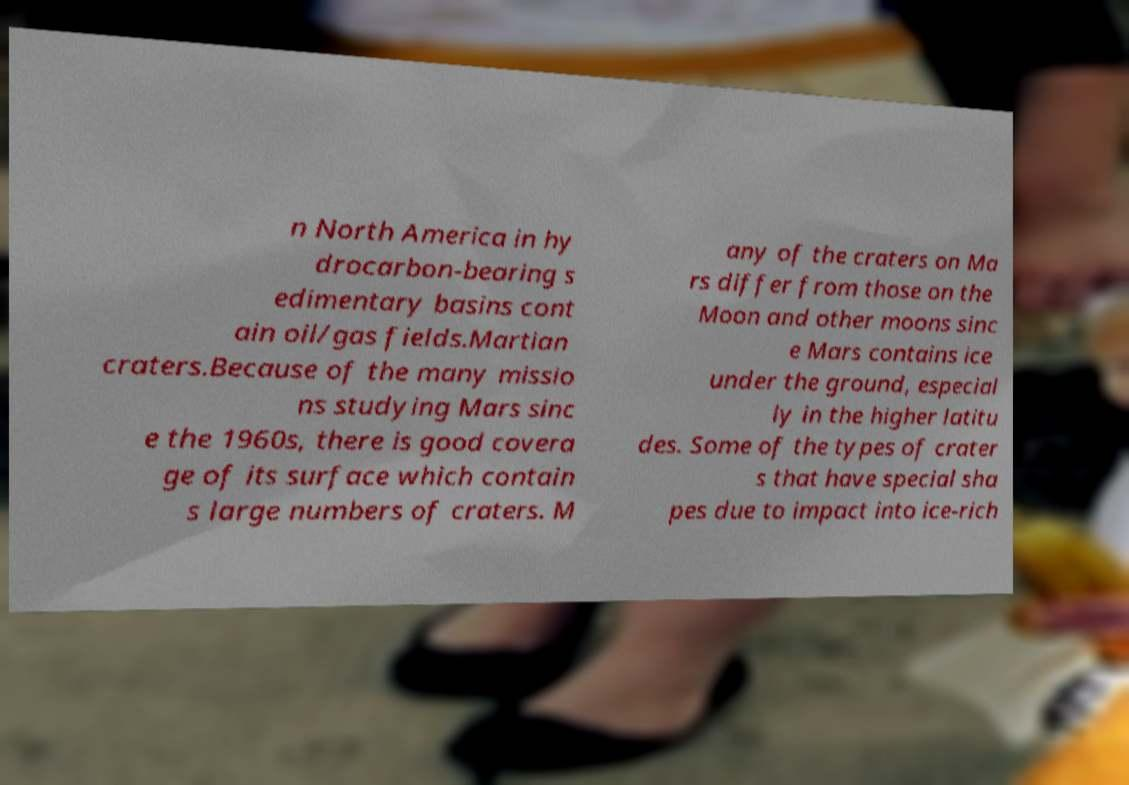Could you extract and type out the text from this image? n North America in hy drocarbon-bearing s edimentary basins cont ain oil/gas fields.Martian craters.Because of the many missio ns studying Mars sinc e the 1960s, there is good covera ge of its surface which contain s large numbers of craters. M any of the craters on Ma rs differ from those on the Moon and other moons sinc e Mars contains ice under the ground, especial ly in the higher latitu des. Some of the types of crater s that have special sha pes due to impact into ice-rich 